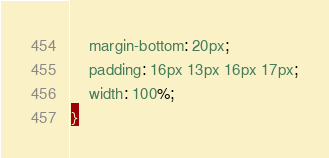Convert code to text. <code><loc_0><loc_0><loc_500><loc_500><_CSS_>    margin-bottom: 20px;
    padding: 16px 13px 16px 17px;
    width: 100%;
}</code> 